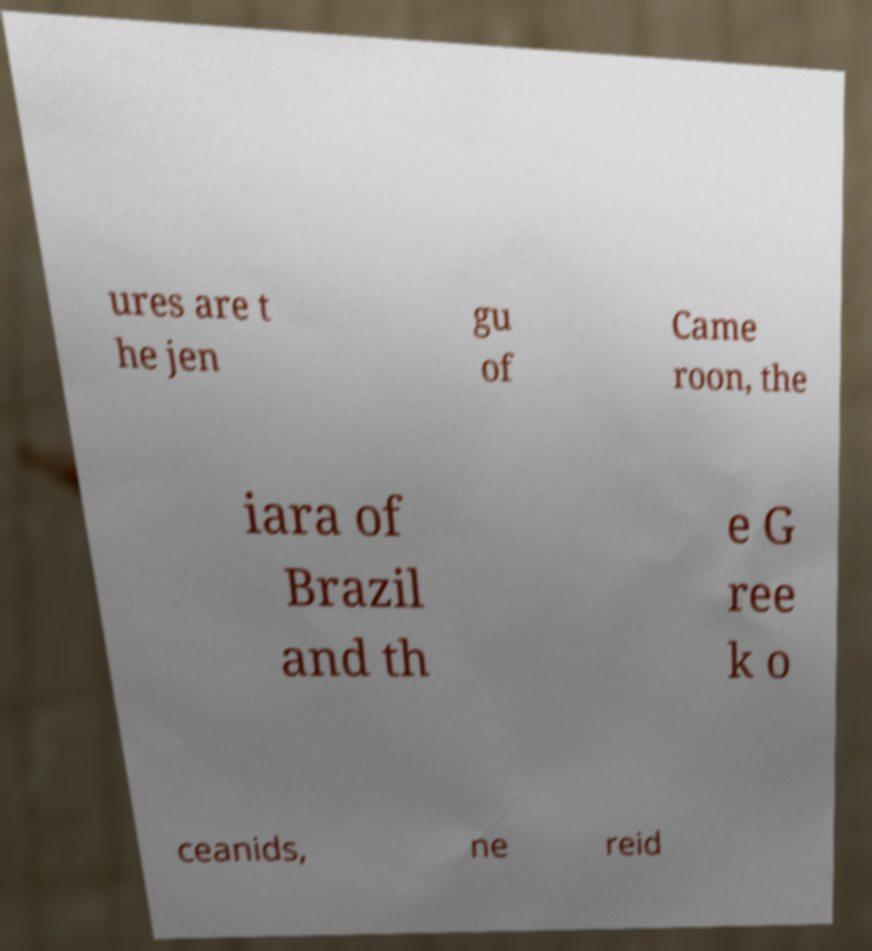Please read and relay the text visible in this image. What does it say? ures are t he jen gu of Came roon, the iara of Brazil and th e G ree k o ceanids, ne reid 